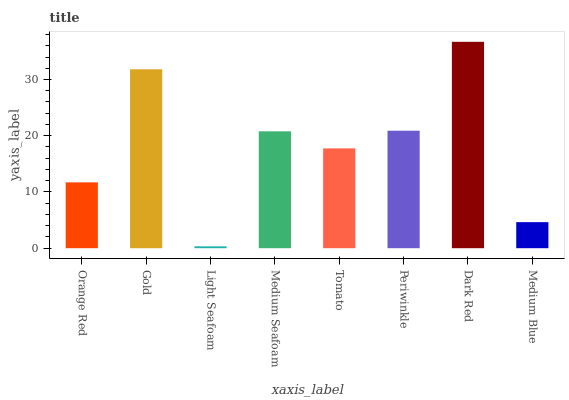Is Light Seafoam the minimum?
Answer yes or no. Yes. Is Dark Red the maximum?
Answer yes or no. Yes. Is Gold the minimum?
Answer yes or no. No. Is Gold the maximum?
Answer yes or no. No. Is Gold greater than Orange Red?
Answer yes or no. Yes. Is Orange Red less than Gold?
Answer yes or no. Yes. Is Orange Red greater than Gold?
Answer yes or no. No. Is Gold less than Orange Red?
Answer yes or no. No. Is Medium Seafoam the high median?
Answer yes or no. Yes. Is Tomato the low median?
Answer yes or no. Yes. Is Dark Red the high median?
Answer yes or no. No. Is Medium Blue the low median?
Answer yes or no. No. 